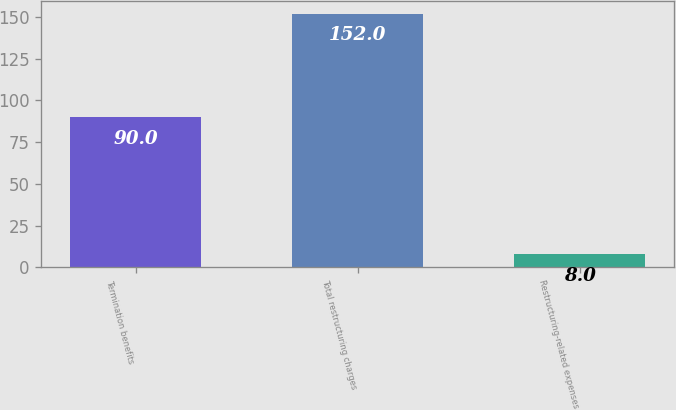Convert chart. <chart><loc_0><loc_0><loc_500><loc_500><bar_chart><fcel>Termination benefits<fcel>Total restructuring charges<fcel>Restructuring-related expenses<nl><fcel>90<fcel>152<fcel>8<nl></chart> 